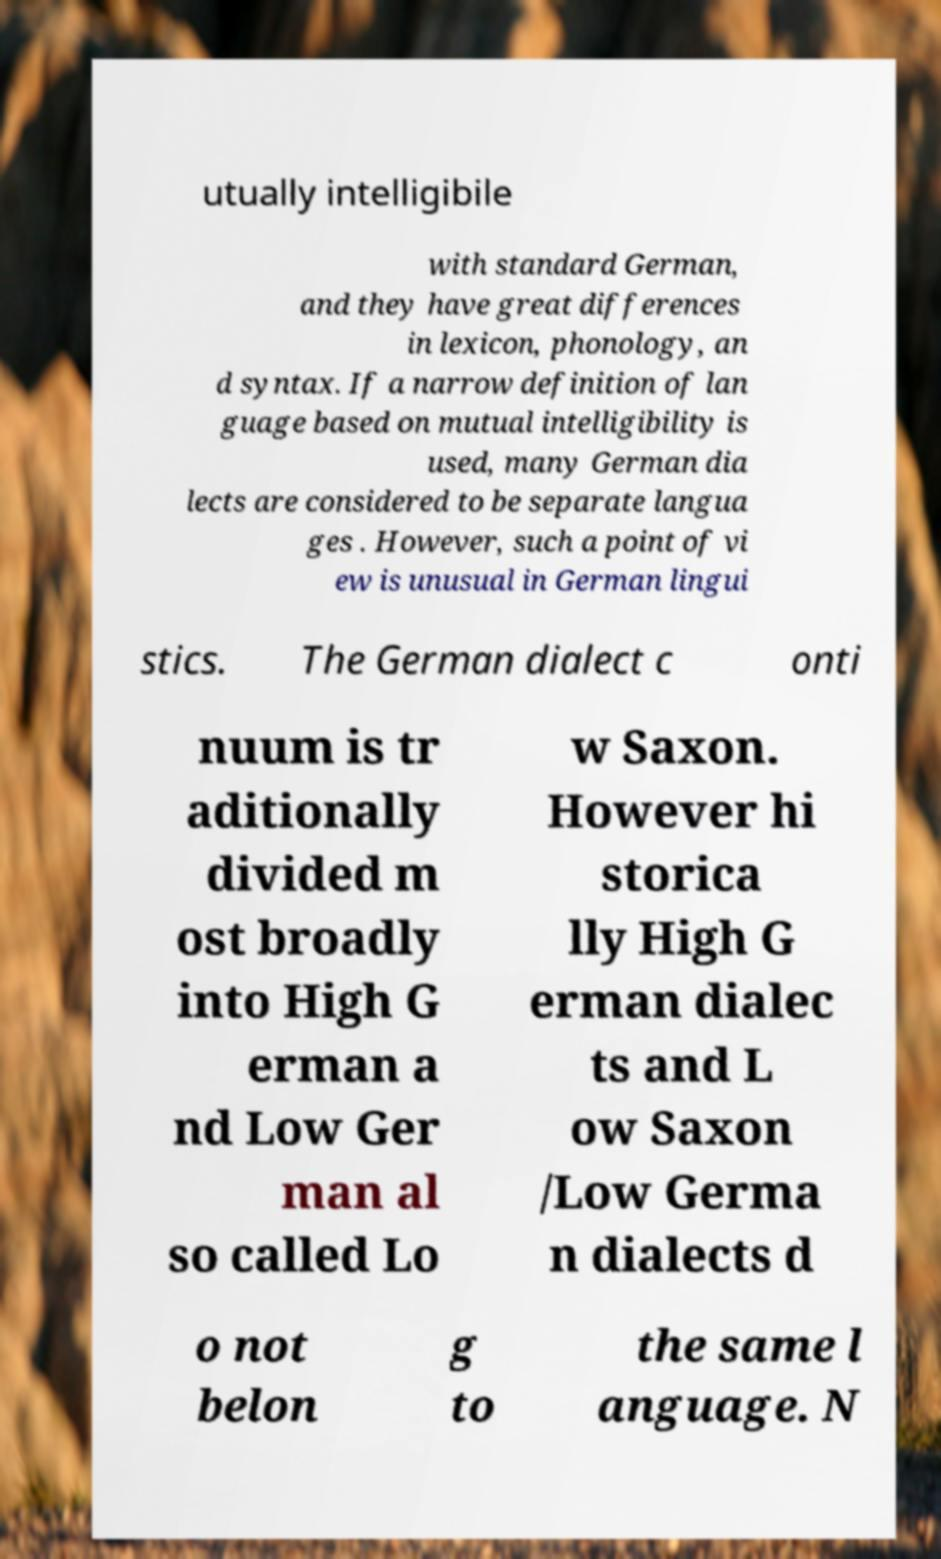Can you accurately transcribe the text from the provided image for me? utually intelligibile with standard German, and they have great differences in lexicon, phonology, an d syntax. If a narrow definition of lan guage based on mutual intelligibility is used, many German dia lects are considered to be separate langua ges . However, such a point of vi ew is unusual in German lingui stics. The German dialect c onti nuum is tr aditionally divided m ost broadly into High G erman a nd Low Ger man al so called Lo w Saxon. However hi storica lly High G erman dialec ts and L ow Saxon /Low Germa n dialects d o not belon g to the same l anguage. N 